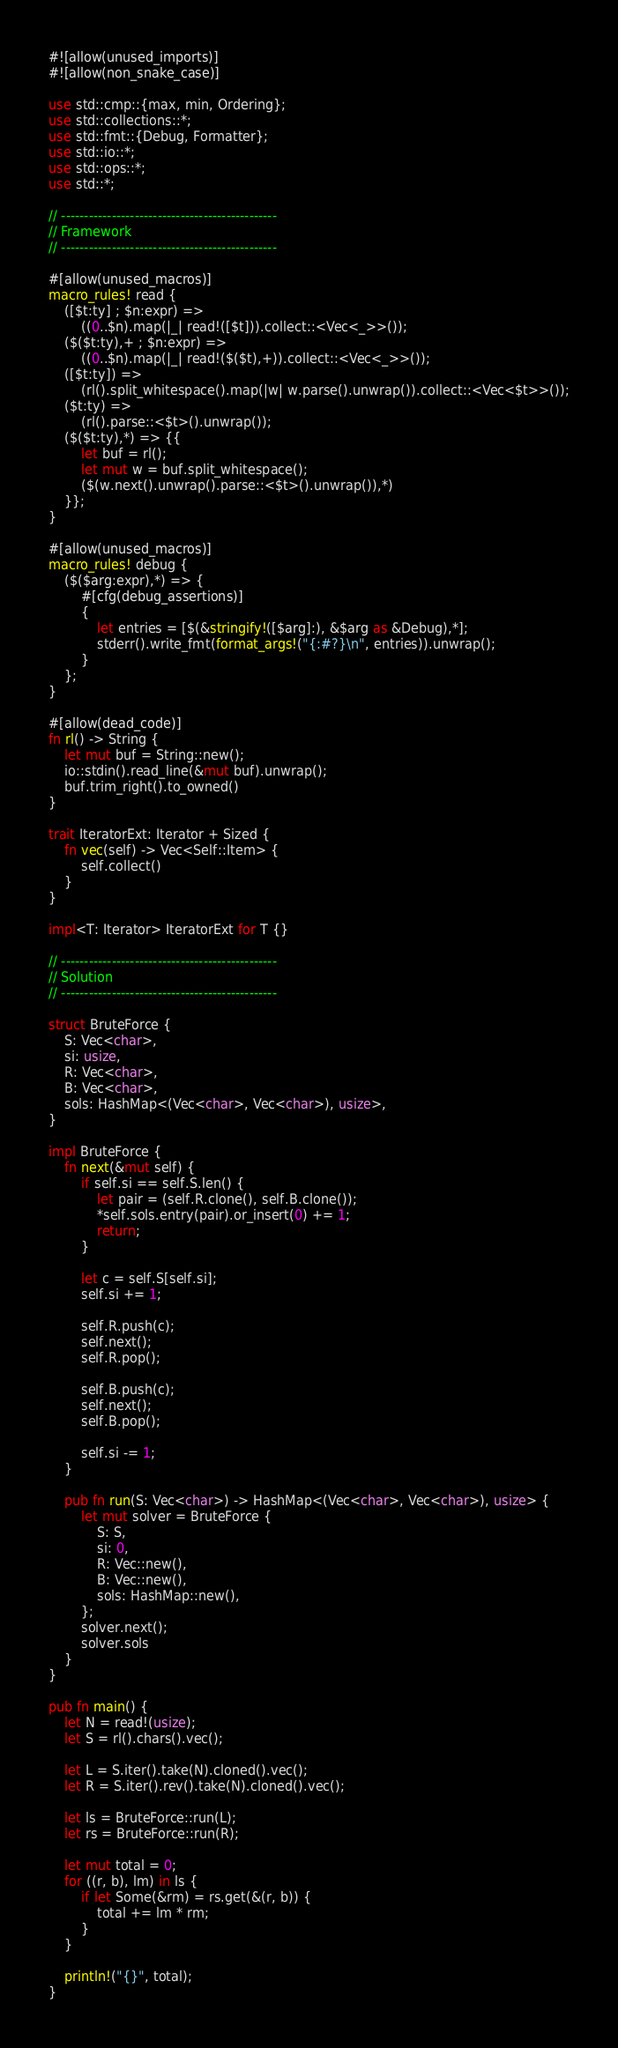Convert code to text. <code><loc_0><loc_0><loc_500><loc_500><_Rust_>#![allow(unused_imports)]
#![allow(non_snake_case)]

use std::cmp::{max, min, Ordering};
use std::collections::*;
use std::fmt::{Debug, Formatter};
use std::io::*;
use std::ops::*;
use std::*;

// -----------------------------------------------
// Framework
// -----------------------------------------------

#[allow(unused_macros)]
macro_rules! read {
    ([$t:ty] ; $n:expr) =>
        ((0..$n).map(|_| read!([$t])).collect::<Vec<_>>());
    ($($t:ty),+ ; $n:expr) =>
        ((0..$n).map(|_| read!($($t),+)).collect::<Vec<_>>());
    ([$t:ty]) =>
        (rl().split_whitespace().map(|w| w.parse().unwrap()).collect::<Vec<$t>>());
    ($t:ty) =>
        (rl().parse::<$t>().unwrap());
    ($($t:ty),*) => {{
        let buf = rl();
        let mut w = buf.split_whitespace();
        ($(w.next().unwrap().parse::<$t>().unwrap()),*)
    }};
}

#[allow(unused_macros)]
macro_rules! debug {
    ($($arg:expr),*) => {
        #[cfg(debug_assertions)]
        {
            let entries = [$(&stringify!([$arg]:), &$arg as &Debug),*];
            stderr().write_fmt(format_args!("{:#?}\n", entries)).unwrap();
        }
    };
}

#[allow(dead_code)]
fn rl() -> String {
    let mut buf = String::new();
    io::stdin().read_line(&mut buf).unwrap();
    buf.trim_right().to_owned()
}

trait IteratorExt: Iterator + Sized {
    fn vec(self) -> Vec<Self::Item> {
        self.collect()
    }
}

impl<T: Iterator> IteratorExt for T {}

// -----------------------------------------------
// Solution
// -----------------------------------------------

struct BruteForce {
    S: Vec<char>,
    si: usize,
    R: Vec<char>,
    B: Vec<char>,
    sols: HashMap<(Vec<char>, Vec<char>), usize>,
}

impl BruteForce {
    fn next(&mut self) {
        if self.si == self.S.len() {
            let pair = (self.R.clone(), self.B.clone());
            *self.sols.entry(pair).or_insert(0) += 1;
            return;
        }

        let c = self.S[self.si];
        self.si += 1;

        self.R.push(c);
        self.next();
        self.R.pop();

        self.B.push(c);
        self.next();
        self.B.pop();

        self.si -= 1;
    }

    pub fn run(S: Vec<char>) -> HashMap<(Vec<char>, Vec<char>), usize> {
        let mut solver = BruteForce {
            S: S,
            si: 0,
            R: Vec::new(),
            B: Vec::new(),
            sols: HashMap::new(),
        };
        solver.next();
        solver.sols
    }
}

pub fn main() {
    let N = read!(usize);
    let S = rl().chars().vec();

    let L = S.iter().take(N).cloned().vec();
    let R = S.iter().rev().take(N).cloned().vec();

    let ls = BruteForce::run(L);
    let rs = BruteForce::run(R);

    let mut total = 0;
    for ((r, b), lm) in ls {
        if let Some(&rm) = rs.get(&(r, b)) {
            total += lm * rm;
        }
    }

    println!("{}", total);
}
</code> 